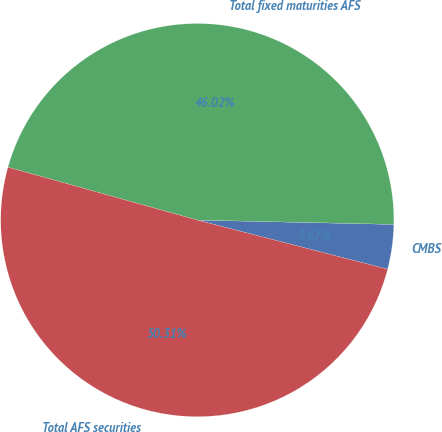Convert chart. <chart><loc_0><loc_0><loc_500><loc_500><pie_chart><fcel>CMBS<fcel>Total fixed maturities AFS<fcel>Total AFS securities<nl><fcel>3.67%<fcel>46.02%<fcel>50.32%<nl></chart> 